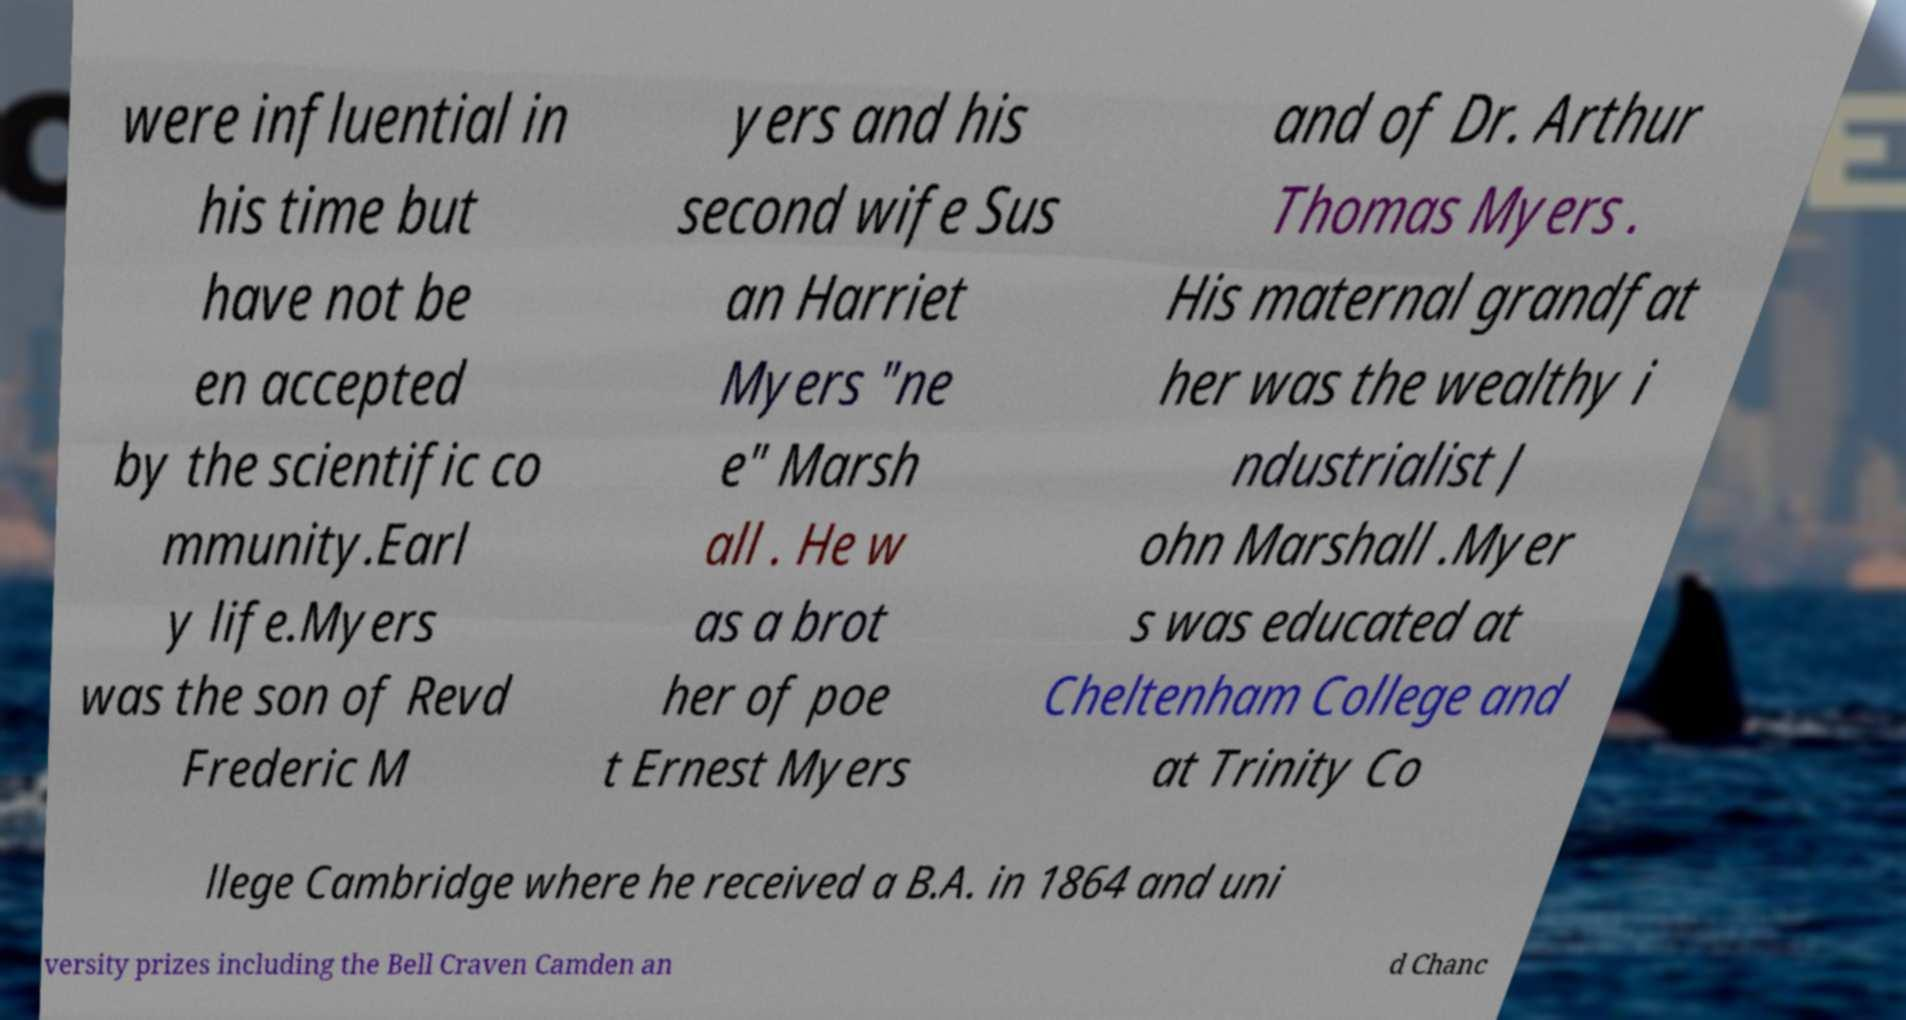Please identify and transcribe the text found in this image. were influential in his time but have not be en accepted by the scientific co mmunity.Earl y life.Myers was the son of Revd Frederic M yers and his second wife Sus an Harriet Myers "ne e" Marsh all . He w as a brot her of poe t Ernest Myers and of Dr. Arthur Thomas Myers . His maternal grandfat her was the wealthy i ndustrialist J ohn Marshall .Myer s was educated at Cheltenham College and at Trinity Co llege Cambridge where he received a B.A. in 1864 and uni versity prizes including the Bell Craven Camden an d Chanc 